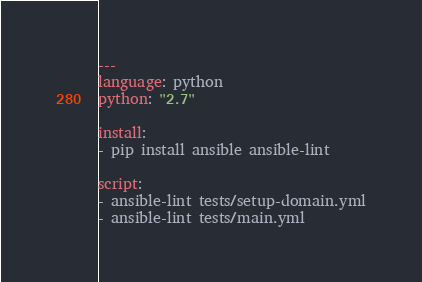<code> <loc_0><loc_0><loc_500><loc_500><_YAML_>---
language: python
python: "2.7"

install:
- pip install ansible ansible-lint

script:
- ansible-lint tests/setup-domain.yml
- ansible-lint tests/main.yml
</code> 